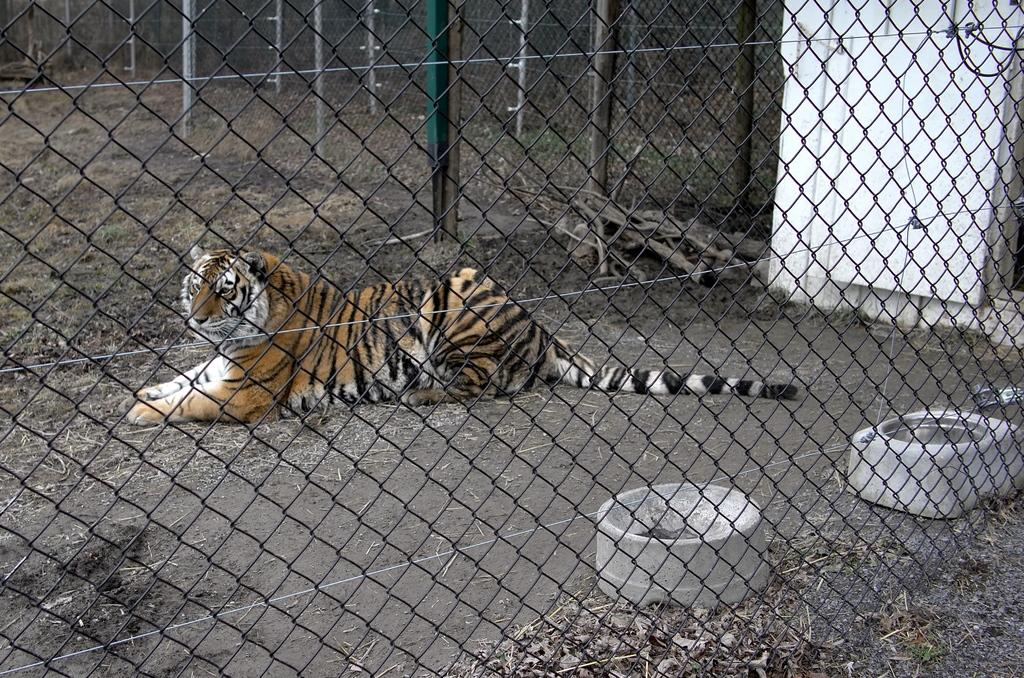What animal is in the image? There is a tiger in the image. What is the tiger doing in the image? The tiger is sitting on the floor. Can you describe the tiger's coloring? The tiger has brown and black coloring. What can be seen near the tiger in the image? There is railing visible in the image. What type of environment is depicted in the background of the image? The background of the image includes green grass. Where is the cobweb located in the image? There is no cobweb present in the image. Who is the creator of the tiger in the image? The image is a photograph or illustration, not a creation by an artist, so there is no specific creator for the tiger in the image. What type of slope can be seen in the image? There is no slope present in the image. 